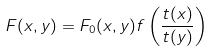Convert formula to latex. <formula><loc_0><loc_0><loc_500><loc_500>F ( x , y ) = F _ { 0 } ( x , y ) f \left ( \frac { t ( x ) } { t ( y ) } \right )</formula> 